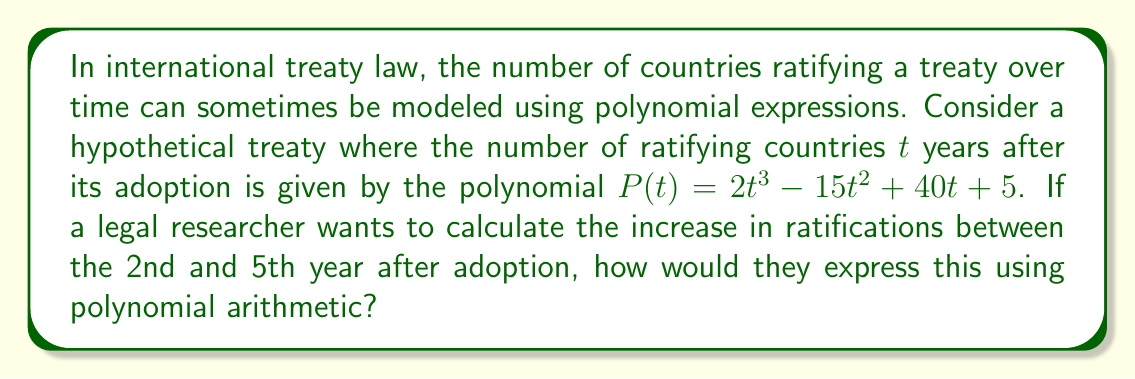Give your solution to this math problem. To solve this problem, we need to follow these steps:

1) First, we need to calculate the number of ratifying countries at year 2 and year 5 using the given polynomial $P(t) = 2t^3 - 15t^2 + 40t + 5$.

2) For year 2:
   $P(2) = 2(2^3) - 15(2^2) + 40(2) + 5$
   $= 2(8) - 15(4) + 80 + 5$
   $= 16 - 60 + 80 + 5$
   $= 41$

3) For year 5:
   $P(5) = 2(5^3) - 15(5^2) + 40(5) + 5$
   $= 2(125) - 15(25) + 200 + 5$
   $= 250 - 375 + 200 + 5$
   $= 80$

4) To find the increase in ratifications, we need to subtract the number of ratifications at year 2 from the number at year 5:

   Increase = $P(5) - P(2) = 80 - 41 = 39$

5) To express this using polynomial arithmetic, we can represent this as:

   $P(5) - P(2) = [2(5^3) - 15(5^2) + 40(5) + 5] - [2(2^3) - 15(2^2) + 40(2) + 5]$

6) This can be simplified to:

   $2(5^3 - 2^3) - 15(5^2 - 2^2) + 40(5 - 2)$

7) Which is equivalent to:

   $2(125 - 8) - 15(25 - 4) + 40(3) = 2(117) - 15(21) + 120 = 234 - 315 + 120 = 39$
Answer: The increase in ratifications between the 2nd and 5th year can be expressed as $P(5) - P(2) = 2(5^3 - 2^3) - 15(5^2 - 2^2) + 40(5 - 2) = 39$ countries. 